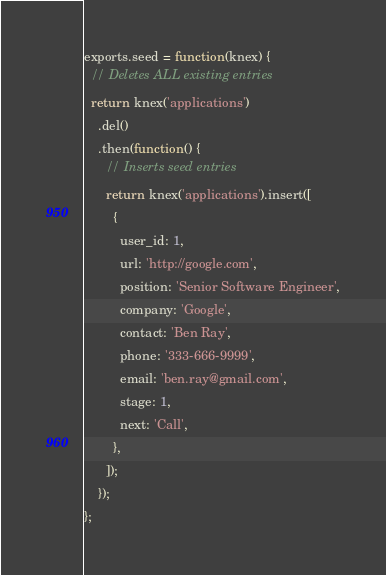Convert code to text. <code><loc_0><loc_0><loc_500><loc_500><_JavaScript_>exports.seed = function(knex) {
  // Deletes ALL existing entries
  return knex('applications')
    .del()
    .then(function() {
      // Inserts seed entries
      return knex('applications').insert([
        {
          user_id: 1,
          url: 'http://google.com',
          position: 'Senior Software Engineer',
          company: 'Google',
          contact: 'Ben Ray',
          phone: '333-666-9999',
          email: 'ben.ray@gmail.com',
          stage: 1,
          next: 'Call',
        },
      ]);
    });
};
</code> 